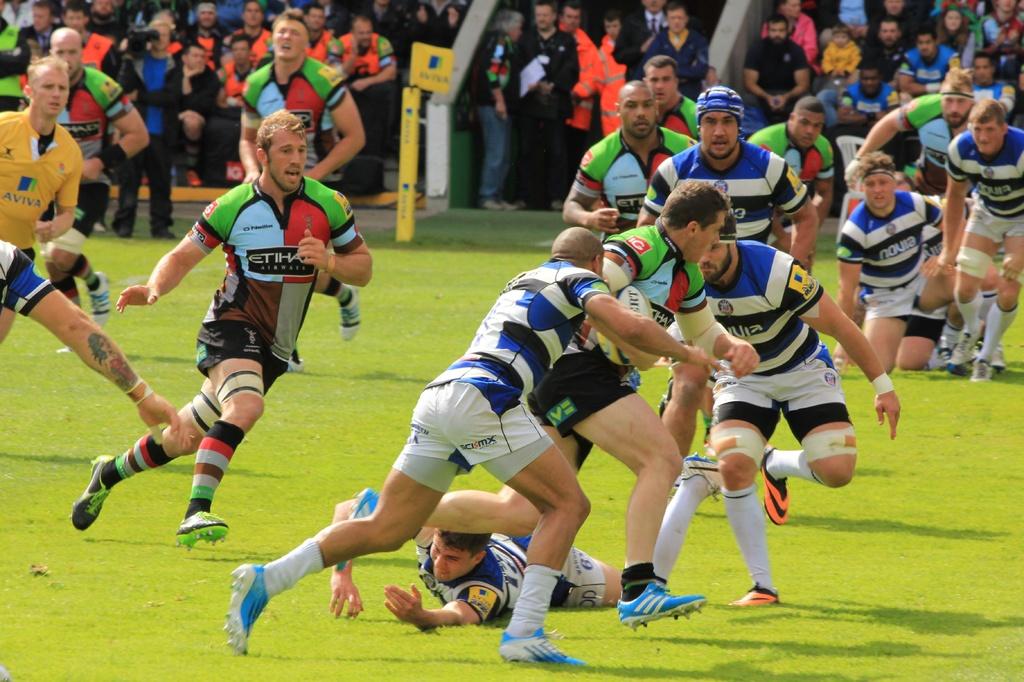What text can you see?
Offer a very short reply. Aviva and novia. 